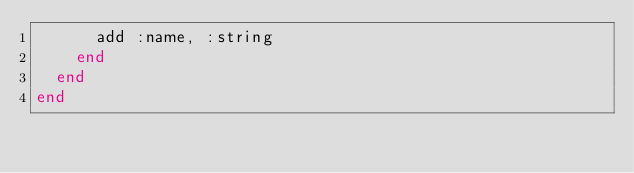<code> <loc_0><loc_0><loc_500><loc_500><_Elixir_>      add :name, :string
    end
  end
end
</code> 